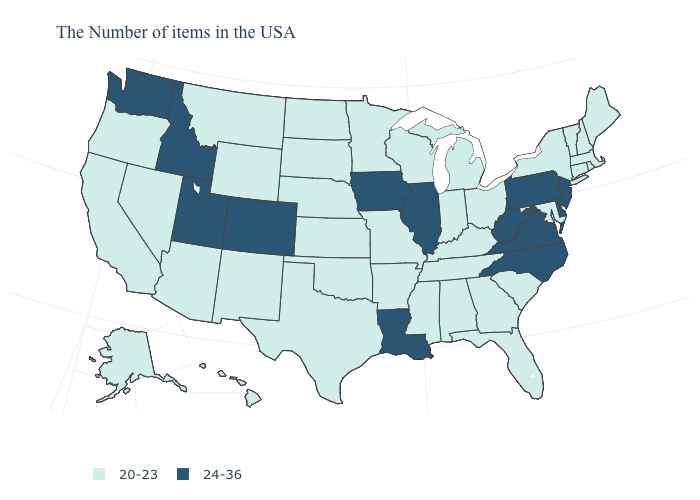Does Colorado have the highest value in the West?
Write a very short answer. Yes. What is the value of Oklahoma?
Concise answer only. 20-23. Does Utah have a higher value than Virginia?
Answer briefly. No. Does Minnesota have the same value as Kentucky?
Keep it brief. Yes. Is the legend a continuous bar?
Write a very short answer. No. Does Colorado have the highest value in the USA?
Write a very short answer. Yes. Does the first symbol in the legend represent the smallest category?
Answer briefly. Yes. Among the states that border Mississippi , which have the lowest value?
Keep it brief. Alabama, Tennessee, Arkansas. Does New Jersey have the lowest value in the Northeast?
Write a very short answer. No. What is the lowest value in the USA?
Write a very short answer. 20-23. Which states have the highest value in the USA?
Give a very brief answer. New Jersey, Delaware, Pennsylvania, Virginia, North Carolina, West Virginia, Illinois, Louisiana, Iowa, Colorado, Utah, Idaho, Washington. Name the states that have a value in the range 24-36?
Be succinct. New Jersey, Delaware, Pennsylvania, Virginia, North Carolina, West Virginia, Illinois, Louisiana, Iowa, Colorado, Utah, Idaho, Washington. Does Idaho have the lowest value in the West?
Keep it brief. No. Which states hav the highest value in the Northeast?
Answer briefly. New Jersey, Pennsylvania. Does North Carolina have the lowest value in the South?
Concise answer only. No. 